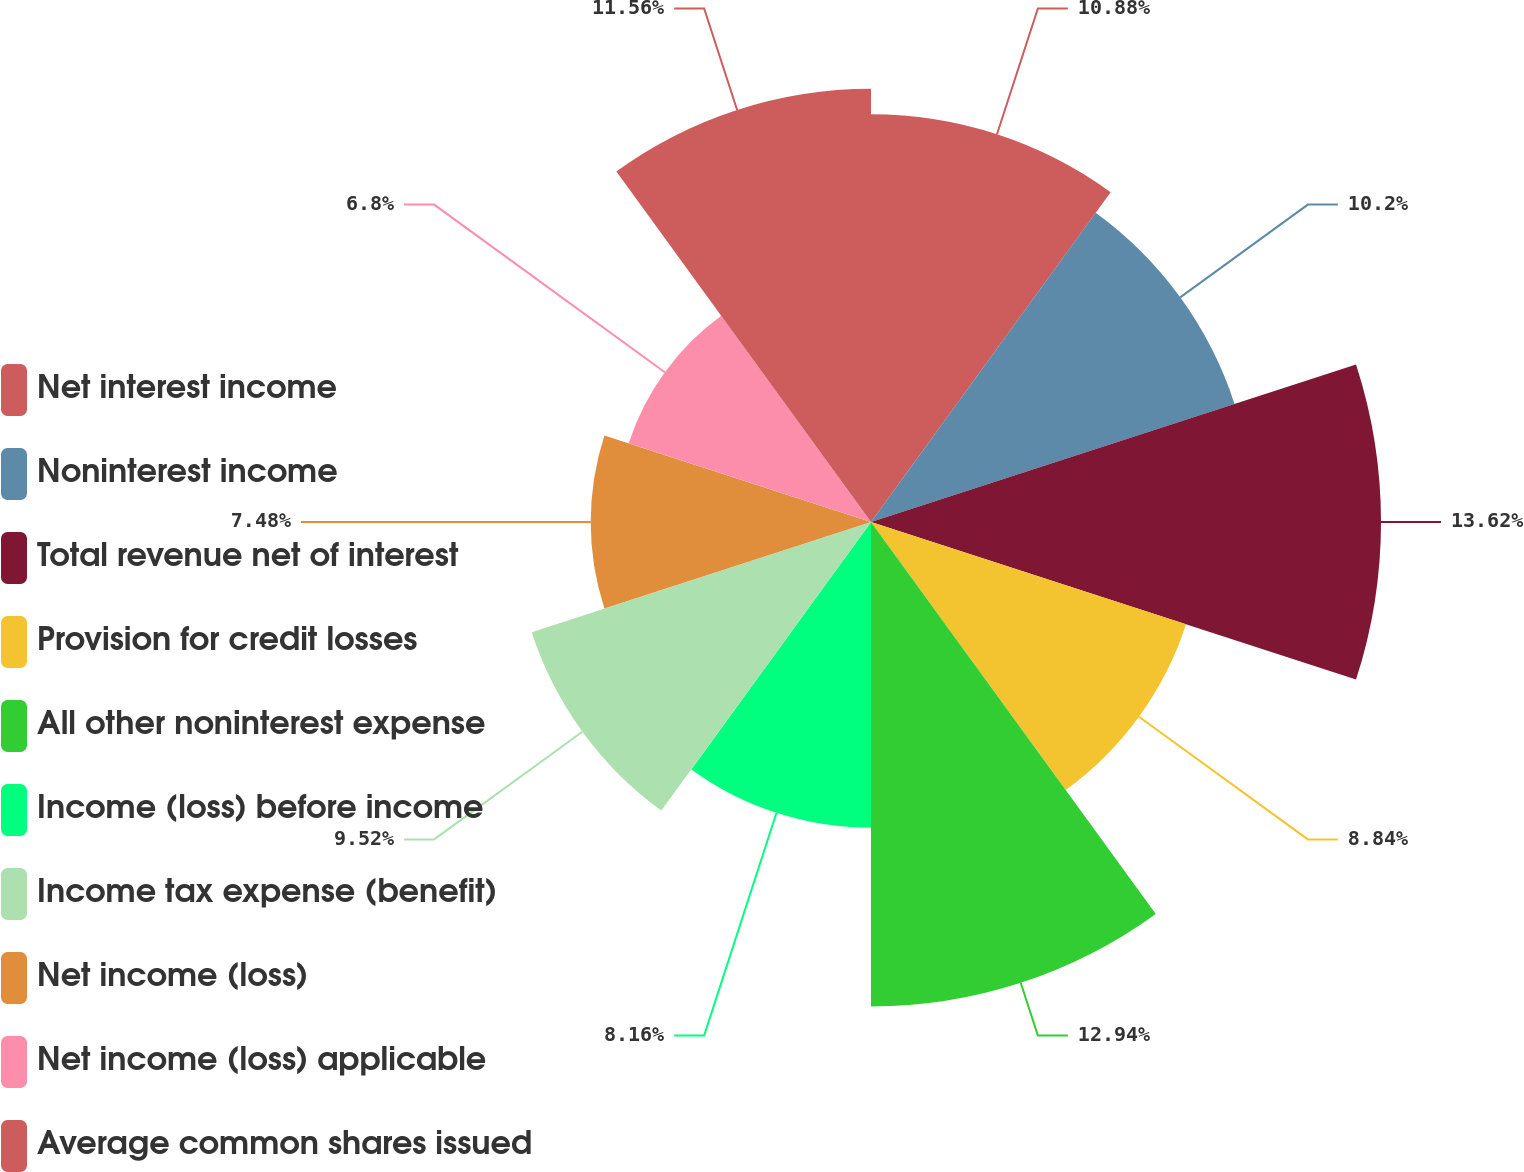<chart> <loc_0><loc_0><loc_500><loc_500><pie_chart><fcel>Net interest income<fcel>Noninterest income<fcel>Total revenue net of interest<fcel>Provision for credit losses<fcel>All other noninterest expense<fcel>Income (loss) before income<fcel>Income tax expense (benefit)<fcel>Net income (loss)<fcel>Net income (loss) applicable<fcel>Average common shares issued<nl><fcel>10.88%<fcel>10.2%<fcel>13.61%<fcel>8.84%<fcel>12.93%<fcel>8.16%<fcel>9.52%<fcel>7.48%<fcel>6.8%<fcel>11.56%<nl></chart> 